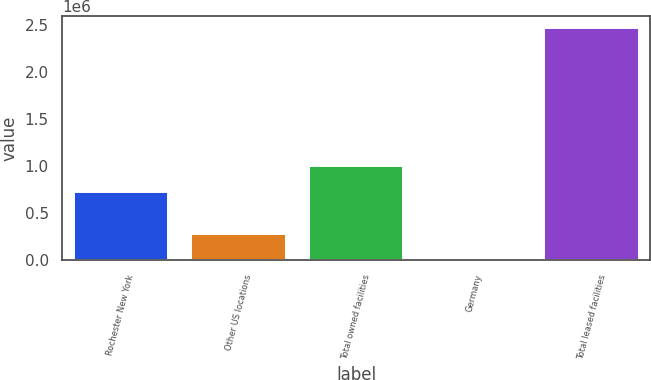Convert chart to OTSL. <chart><loc_0><loc_0><loc_500><loc_500><bar_chart><fcel>Rochester New York<fcel>Other US locations<fcel>Total owned facilities<fcel>Germany<fcel>Total leased facilities<nl><fcel>721000<fcel>280000<fcel>1.001e+06<fcel>1000<fcel>2.468e+06<nl></chart> 